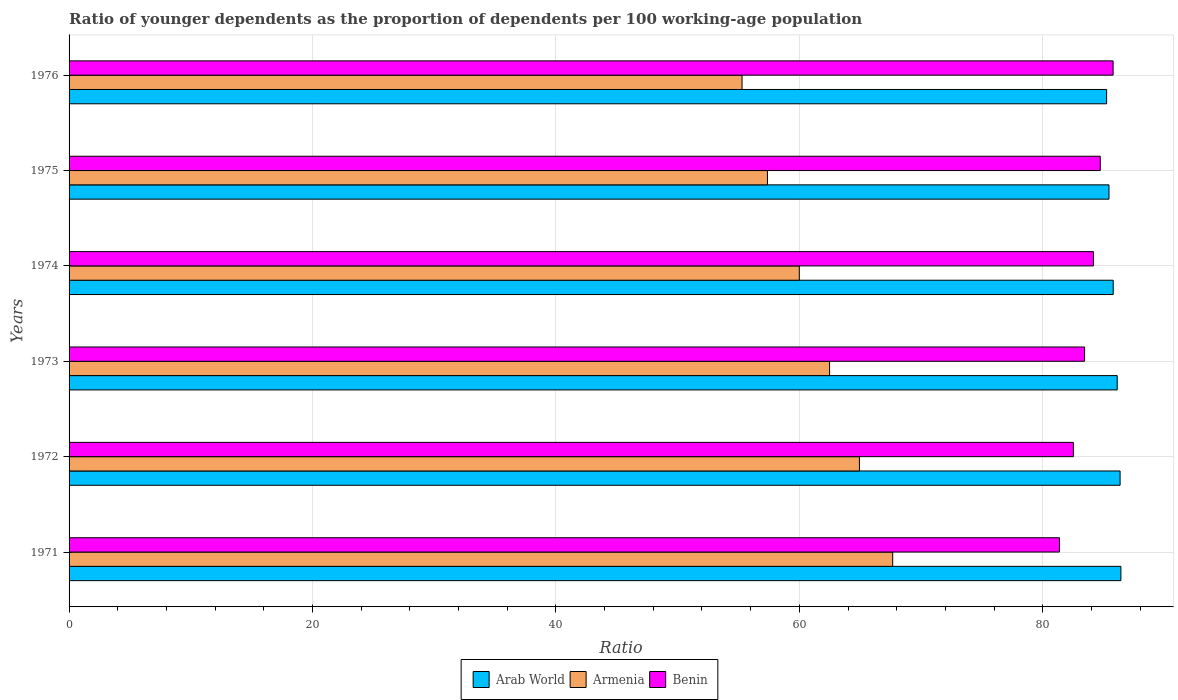Are the number of bars per tick equal to the number of legend labels?
Make the answer very short. Yes. How many bars are there on the 2nd tick from the top?
Ensure brevity in your answer.  3. What is the label of the 4th group of bars from the top?
Offer a terse response. 1973. In how many cases, is the number of bars for a given year not equal to the number of legend labels?
Keep it short and to the point. 0. What is the age dependency ratio(young) in Armenia in 1976?
Offer a very short reply. 55.29. Across all years, what is the maximum age dependency ratio(young) in Armenia?
Offer a very short reply. 67.67. Across all years, what is the minimum age dependency ratio(young) in Armenia?
Make the answer very short. 55.29. In which year was the age dependency ratio(young) in Arab World minimum?
Your response must be concise. 1976. What is the total age dependency ratio(young) in Armenia in the graph?
Provide a short and direct response. 367.76. What is the difference between the age dependency ratio(young) in Benin in 1975 and that in 1976?
Provide a short and direct response. -1.06. What is the difference between the age dependency ratio(young) in Armenia in 1971 and the age dependency ratio(young) in Benin in 1974?
Offer a terse response. -16.49. What is the average age dependency ratio(young) in Armenia per year?
Provide a short and direct response. 61.29. In the year 1971, what is the difference between the age dependency ratio(young) in Armenia and age dependency ratio(young) in Arab World?
Give a very brief answer. -18.75. In how many years, is the age dependency ratio(young) in Arab World greater than 48 ?
Provide a short and direct response. 6. What is the ratio of the age dependency ratio(young) in Armenia in 1971 to that in 1973?
Keep it short and to the point. 1.08. What is the difference between the highest and the second highest age dependency ratio(young) in Arab World?
Give a very brief answer. 0.07. What is the difference between the highest and the lowest age dependency ratio(young) in Armenia?
Ensure brevity in your answer.  12.38. What does the 2nd bar from the top in 1973 represents?
Your response must be concise. Armenia. What does the 1st bar from the bottom in 1974 represents?
Offer a very short reply. Arab World. How many bars are there?
Your answer should be very brief. 18. How many years are there in the graph?
Your answer should be compact. 6. What is the difference between two consecutive major ticks on the X-axis?
Offer a terse response. 20. Does the graph contain any zero values?
Make the answer very short. No. Does the graph contain grids?
Give a very brief answer. Yes. How many legend labels are there?
Your answer should be very brief. 3. How are the legend labels stacked?
Ensure brevity in your answer.  Horizontal. What is the title of the graph?
Keep it short and to the point. Ratio of younger dependents as the proportion of dependents per 100 working-age population. Does "Ethiopia" appear as one of the legend labels in the graph?
Provide a succinct answer. No. What is the label or title of the X-axis?
Your answer should be very brief. Ratio. What is the Ratio of Arab World in 1971?
Offer a terse response. 86.42. What is the Ratio in Armenia in 1971?
Offer a terse response. 67.67. What is the Ratio of Benin in 1971?
Your answer should be very brief. 81.37. What is the Ratio of Arab World in 1972?
Your answer should be very brief. 86.35. What is the Ratio of Armenia in 1972?
Keep it short and to the point. 64.94. What is the Ratio of Benin in 1972?
Your answer should be very brief. 82.52. What is the Ratio in Arab World in 1973?
Give a very brief answer. 86.12. What is the Ratio in Armenia in 1973?
Offer a very short reply. 62.48. What is the Ratio in Benin in 1973?
Ensure brevity in your answer.  83.44. What is the Ratio of Arab World in 1974?
Offer a very short reply. 85.79. What is the Ratio in Armenia in 1974?
Offer a terse response. 60. What is the Ratio in Benin in 1974?
Provide a short and direct response. 84.16. What is the Ratio in Arab World in 1975?
Ensure brevity in your answer.  85.44. What is the Ratio in Armenia in 1975?
Your response must be concise. 57.38. What is the Ratio of Benin in 1975?
Your response must be concise. 84.72. What is the Ratio of Arab World in 1976?
Your response must be concise. 85.25. What is the Ratio of Armenia in 1976?
Keep it short and to the point. 55.29. What is the Ratio of Benin in 1976?
Offer a terse response. 85.78. Across all years, what is the maximum Ratio in Arab World?
Your answer should be very brief. 86.42. Across all years, what is the maximum Ratio in Armenia?
Ensure brevity in your answer.  67.67. Across all years, what is the maximum Ratio in Benin?
Provide a short and direct response. 85.78. Across all years, what is the minimum Ratio in Arab World?
Keep it short and to the point. 85.25. Across all years, what is the minimum Ratio of Armenia?
Keep it short and to the point. 55.29. Across all years, what is the minimum Ratio of Benin?
Make the answer very short. 81.37. What is the total Ratio in Arab World in the graph?
Keep it short and to the point. 515.36. What is the total Ratio in Armenia in the graph?
Provide a short and direct response. 367.76. What is the total Ratio of Benin in the graph?
Provide a succinct answer. 501.99. What is the difference between the Ratio in Arab World in 1971 and that in 1972?
Give a very brief answer. 0.07. What is the difference between the Ratio in Armenia in 1971 and that in 1972?
Make the answer very short. 2.73. What is the difference between the Ratio of Benin in 1971 and that in 1972?
Your answer should be compact. -1.14. What is the difference between the Ratio of Arab World in 1971 and that in 1973?
Offer a very short reply. 0.3. What is the difference between the Ratio in Armenia in 1971 and that in 1973?
Ensure brevity in your answer.  5.19. What is the difference between the Ratio of Benin in 1971 and that in 1973?
Give a very brief answer. -2.06. What is the difference between the Ratio of Arab World in 1971 and that in 1974?
Provide a succinct answer. 0.63. What is the difference between the Ratio in Armenia in 1971 and that in 1974?
Make the answer very short. 7.67. What is the difference between the Ratio in Benin in 1971 and that in 1974?
Provide a succinct answer. -2.79. What is the difference between the Ratio in Arab World in 1971 and that in 1975?
Ensure brevity in your answer.  0.98. What is the difference between the Ratio of Armenia in 1971 and that in 1975?
Make the answer very short. 10.29. What is the difference between the Ratio of Benin in 1971 and that in 1975?
Your response must be concise. -3.35. What is the difference between the Ratio in Arab World in 1971 and that in 1976?
Keep it short and to the point. 1.17. What is the difference between the Ratio of Armenia in 1971 and that in 1976?
Offer a very short reply. 12.38. What is the difference between the Ratio in Benin in 1971 and that in 1976?
Your answer should be very brief. -4.41. What is the difference between the Ratio of Arab World in 1972 and that in 1973?
Your response must be concise. 0.24. What is the difference between the Ratio in Armenia in 1972 and that in 1973?
Provide a short and direct response. 2.45. What is the difference between the Ratio in Benin in 1972 and that in 1973?
Provide a succinct answer. -0.92. What is the difference between the Ratio in Arab World in 1972 and that in 1974?
Provide a succinct answer. 0.56. What is the difference between the Ratio in Armenia in 1972 and that in 1974?
Give a very brief answer. 4.94. What is the difference between the Ratio in Benin in 1972 and that in 1974?
Provide a short and direct response. -1.65. What is the difference between the Ratio in Arab World in 1972 and that in 1975?
Your response must be concise. 0.91. What is the difference between the Ratio in Armenia in 1972 and that in 1975?
Keep it short and to the point. 7.56. What is the difference between the Ratio in Benin in 1972 and that in 1975?
Your response must be concise. -2.21. What is the difference between the Ratio in Arab World in 1972 and that in 1976?
Ensure brevity in your answer.  1.11. What is the difference between the Ratio in Armenia in 1972 and that in 1976?
Provide a succinct answer. 9.64. What is the difference between the Ratio of Benin in 1972 and that in 1976?
Ensure brevity in your answer.  -3.26. What is the difference between the Ratio of Arab World in 1973 and that in 1974?
Your response must be concise. 0.33. What is the difference between the Ratio of Armenia in 1973 and that in 1974?
Your response must be concise. 2.49. What is the difference between the Ratio in Benin in 1973 and that in 1974?
Keep it short and to the point. -0.73. What is the difference between the Ratio in Arab World in 1973 and that in 1975?
Ensure brevity in your answer.  0.68. What is the difference between the Ratio of Armenia in 1973 and that in 1975?
Your answer should be very brief. 5.1. What is the difference between the Ratio in Benin in 1973 and that in 1975?
Ensure brevity in your answer.  -1.29. What is the difference between the Ratio of Arab World in 1973 and that in 1976?
Give a very brief answer. 0.87. What is the difference between the Ratio of Armenia in 1973 and that in 1976?
Your answer should be very brief. 7.19. What is the difference between the Ratio of Benin in 1973 and that in 1976?
Make the answer very short. -2.34. What is the difference between the Ratio of Arab World in 1974 and that in 1975?
Provide a succinct answer. 0.35. What is the difference between the Ratio in Armenia in 1974 and that in 1975?
Offer a terse response. 2.62. What is the difference between the Ratio in Benin in 1974 and that in 1975?
Give a very brief answer. -0.56. What is the difference between the Ratio of Arab World in 1974 and that in 1976?
Your answer should be compact. 0.54. What is the difference between the Ratio of Armenia in 1974 and that in 1976?
Your response must be concise. 4.7. What is the difference between the Ratio of Benin in 1974 and that in 1976?
Provide a short and direct response. -1.62. What is the difference between the Ratio of Arab World in 1975 and that in 1976?
Ensure brevity in your answer.  0.19. What is the difference between the Ratio in Armenia in 1975 and that in 1976?
Make the answer very short. 2.09. What is the difference between the Ratio in Benin in 1975 and that in 1976?
Your response must be concise. -1.06. What is the difference between the Ratio of Arab World in 1971 and the Ratio of Armenia in 1972?
Offer a terse response. 21.48. What is the difference between the Ratio of Arab World in 1971 and the Ratio of Benin in 1972?
Your answer should be compact. 3.9. What is the difference between the Ratio of Armenia in 1971 and the Ratio of Benin in 1972?
Provide a short and direct response. -14.85. What is the difference between the Ratio of Arab World in 1971 and the Ratio of Armenia in 1973?
Keep it short and to the point. 23.94. What is the difference between the Ratio in Arab World in 1971 and the Ratio in Benin in 1973?
Provide a succinct answer. 2.98. What is the difference between the Ratio in Armenia in 1971 and the Ratio in Benin in 1973?
Provide a short and direct response. -15.77. What is the difference between the Ratio of Arab World in 1971 and the Ratio of Armenia in 1974?
Provide a succinct answer. 26.42. What is the difference between the Ratio of Arab World in 1971 and the Ratio of Benin in 1974?
Provide a short and direct response. 2.26. What is the difference between the Ratio in Armenia in 1971 and the Ratio in Benin in 1974?
Offer a terse response. -16.49. What is the difference between the Ratio in Arab World in 1971 and the Ratio in Armenia in 1975?
Your answer should be very brief. 29.04. What is the difference between the Ratio in Arab World in 1971 and the Ratio in Benin in 1975?
Keep it short and to the point. 1.7. What is the difference between the Ratio of Armenia in 1971 and the Ratio of Benin in 1975?
Your response must be concise. -17.05. What is the difference between the Ratio of Arab World in 1971 and the Ratio of Armenia in 1976?
Your answer should be compact. 31.13. What is the difference between the Ratio of Arab World in 1971 and the Ratio of Benin in 1976?
Provide a short and direct response. 0.64. What is the difference between the Ratio of Armenia in 1971 and the Ratio of Benin in 1976?
Keep it short and to the point. -18.11. What is the difference between the Ratio in Arab World in 1972 and the Ratio in Armenia in 1973?
Offer a very short reply. 23.87. What is the difference between the Ratio of Arab World in 1972 and the Ratio of Benin in 1973?
Your answer should be compact. 2.92. What is the difference between the Ratio in Armenia in 1972 and the Ratio in Benin in 1973?
Provide a succinct answer. -18.5. What is the difference between the Ratio in Arab World in 1972 and the Ratio in Armenia in 1974?
Offer a terse response. 26.36. What is the difference between the Ratio in Arab World in 1972 and the Ratio in Benin in 1974?
Offer a very short reply. 2.19. What is the difference between the Ratio in Armenia in 1972 and the Ratio in Benin in 1974?
Your response must be concise. -19.23. What is the difference between the Ratio of Arab World in 1972 and the Ratio of Armenia in 1975?
Your response must be concise. 28.97. What is the difference between the Ratio in Arab World in 1972 and the Ratio in Benin in 1975?
Give a very brief answer. 1.63. What is the difference between the Ratio in Armenia in 1972 and the Ratio in Benin in 1975?
Make the answer very short. -19.79. What is the difference between the Ratio of Arab World in 1972 and the Ratio of Armenia in 1976?
Your answer should be compact. 31.06. What is the difference between the Ratio of Arab World in 1972 and the Ratio of Benin in 1976?
Offer a terse response. 0.57. What is the difference between the Ratio in Armenia in 1972 and the Ratio in Benin in 1976?
Your response must be concise. -20.84. What is the difference between the Ratio in Arab World in 1973 and the Ratio in Armenia in 1974?
Offer a very short reply. 26.12. What is the difference between the Ratio of Arab World in 1973 and the Ratio of Benin in 1974?
Keep it short and to the point. 1.95. What is the difference between the Ratio of Armenia in 1973 and the Ratio of Benin in 1974?
Offer a terse response. -21.68. What is the difference between the Ratio in Arab World in 1973 and the Ratio in Armenia in 1975?
Make the answer very short. 28.74. What is the difference between the Ratio in Arab World in 1973 and the Ratio in Benin in 1975?
Provide a succinct answer. 1.39. What is the difference between the Ratio of Armenia in 1973 and the Ratio of Benin in 1975?
Offer a terse response. -22.24. What is the difference between the Ratio of Arab World in 1973 and the Ratio of Armenia in 1976?
Offer a very short reply. 30.82. What is the difference between the Ratio of Arab World in 1973 and the Ratio of Benin in 1976?
Give a very brief answer. 0.34. What is the difference between the Ratio in Armenia in 1973 and the Ratio in Benin in 1976?
Your answer should be compact. -23.3. What is the difference between the Ratio in Arab World in 1974 and the Ratio in Armenia in 1975?
Ensure brevity in your answer.  28.41. What is the difference between the Ratio of Arab World in 1974 and the Ratio of Benin in 1975?
Provide a succinct answer. 1.07. What is the difference between the Ratio in Armenia in 1974 and the Ratio in Benin in 1975?
Make the answer very short. -24.73. What is the difference between the Ratio of Arab World in 1974 and the Ratio of Armenia in 1976?
Ensure brevity in your answer.  30.5. What is the difference between the Ratio in Arab World in 1974 and the Ratio in Benin in 1976?
Make the answer very short. 0.01. What is the difference between the Ratio in Armenia in 1974 and the Ratio in Benin in 1976?
Offer a terse response. -25.78. What is the difference between the Ratio in Arab World in 1975 and the Ratio in Armenia in 1976?
Make the answer very short. 30.15. What is the difference between the Ratio in Arab World in 1975 and the Ratio in Benin in 1976?
Offer a terse response. -0.34. What is the difference between the Ratio in Armenia in 1975 and the Ratio in Benin in 1976?
Ensure brevity in your answer.  -28.4. What is the average Ratio of Arab World per year?
Your answer should be compact. 85.89. What is the average Ratio of Armenia per year?
Ensure brevity in your answer.  61.29. What is the average Ratio in Benin per year?
Offer a terse response. 83.66. In the year 1971, what is the difference between the Ratio in Arab World and Ratio in Armenia?
Offer a terse response. 18.75. In the year 1971, what is the difference between the Ratio of Arab World and Ratio of Benin?
Your response must be concise. 5.05. In the year 1971, what is the difference between the Ratio of Armenia and Ratio of Benin?
Ensure brevity in your answer.  -13.7. In the year 1972, what is the difference between the Ratio in Arab World and Ratio in Armenia?
Provide a succinct answer. 21.42. In the year 1972, what is the difference between the Ratio in Arab World and Ratio in Benin?
Your answer should be compact. 3.84. In the year 1972, what is the difference between the Ratio of Armenia and Ratio of Benin?
Give a very brief answer. -17.58. In the year 1973, what is the difference between the Ratio of Arab World and Ratio of Armenia?
Offer a terse response. 23.63. In the year 1973, what is the difference between the Ratio in Arab World and Ratio in Benin?
Offer a terse response. 2.68. In the year 1973, what is the difference between the Ratio in Armenia and Ratio in Benin?
Ensure brevity in your answer.  -20.95. In the year 1974, what is the difference between the Ratio in Arab World and Ratio in Armenia?
Your answer should be very brief. 25.79. In the year 1974, what is the difference between the Ratio in Arab World and Ratio in Benin?
Provide a short and direct response. 1.62. In the year 1974, what is the difference between the Ratio of Armenia and Ratio of Benin?
Keep it short and to the point. -24.17. In the year 1975, what is the difference between the Ratio of Arab World and Ratio of Armenia?
Keep it short and to the point. 28.06. In the year 1975, what is the difference between the Ratio of Arab World and Ratio of Benin?
Your answer should be compact. 0.72. In the year 1975, what is the difference between the Ratio of Armenia and Ratio of Benin?
Offer a terse response. -27.34. In the year 1976, what is the difference between the Ratio in Arab World and Ratio in Armenia?
Keep it short and to the point. 29.95. In the year 1976, what is the difference between the Ratio of Arab World and Ratio of Benin?
Keep it short and to the point. -0.53. In the year 1976, what is the difference between the Ratio in Armenia and Ratio in Benin?
Keep it short and to the point. -30.49. What is the ratio of the Ratio in Armenia in 1971 to that in 1972?
Your answer should be compact. 1.04. What is the ratio of the Ratio in Benin in 1971 to that in 1972?
Your answer should be very brief. 0.99. What is the ratio of the Ratio in Armenia in 1971 to that in 1973?
Provide a succinct answer. 1.08. What is the ratio of the Ratio in Benin in 1971 to that in 1973?
Give a very brief answer. 0.98. What is the ratio of the Ratio in Arab World in 1971 to that in 1974?
Offer a very short reply. 1.01. What is the ratio of the Ratio in Armenia in 1971 to that in 1974?
Your answer should be compact. 1.13. What is the ratio of the Ratio of Benin in 1971 to that in 1974?
Provide a succinct answer. 0.97. What is the ratio of the Ratio of Arab World in 1971 to that in 1975?
Your answer should be compact. 1.01. What is the ratio of the Ratio of Armenia in 1971 to that in 1975?
Your answer should be compact. 1.18. What is the ratio of the Ratio of Benin in 1971 to that in 1975?
Give a very brief answer. 0.96. What is the ratio of the Ratio in Arab World in 1971 to that in 1976?
Keep it short and to the point. 1.01. What is the ratio of the Ratio in Armenia in 1971 to that in 1976?
Your answer should be very brief. 1.22. What is the ratio of the Ratio of Benin in 1971 to that in 1976?
Provide a short and direct response. 0.95. What is the ratio of the Ratio in Arab World in 1972 to that in 1973?
Offer a terse response. 1. What is the ratio of the Ratio of Armenia in 1972 to that in 1973?
Your response must be concise. 1.04. What is the ratio of the Ratio in Arab World in 1972 to that in 1974?
Give a very brief answer. 1.01. What is the ratio of the Ratio of Armenia in 1972 to that in 1974?
Make the answer very short. 1.08. What is the ratio of the Ratio in Benin in 1972 to that in 1974?
Your answer should be compact. 0.98. What is the ratio of the Ratio of Arab World in 1972 to that in 1975?
Offer a very short reply. 1.01. What is the ratio of the Ratio in Armenia in 1972 to that in 1975?
Offer a terse response. 1.13. What is the ratio of the Ratio of Benin in 1972 to that in 1975?
Offer a very short reply. 0.97. What is the ratio of the Ratio of Arab World in 1972 to that in 1976?
Your answer should be compact. 1.01. What is the ratio of the Ratio in Armenia in 1972 to that in 1976?
Offer a very short reply. 1.17. What is the ratio of the Ratio in Armenia in 1973 to that in 1974?
Ensure brevity in your answer.  1.04. What is the ratio of the Ratio in Benin in 1973 to that in 1974?
Offer a very short reply. 0.99. What is the ratio of the Ratio in Arab World in 1973 to that in 1975?
Provide a short and direct response. 1.01. What is the ratio of the Ratio in Armenia in 1973 to that in 1975?
Your answer should be compact. 1.09. What is the ratio of the Ratio of Arab World in 1973 to that in 1976?
Offer a terse response. 1.01. What is the ratio of the Ratio in Armenia in 1973 to that in 1976?
Your response must be concise. 1.13. What is the ratio of the Ratio of Benin in 1973 to that in 1976?
Your answer should be compact. 0.97. What is the ratio of the Ratio of Armenia in 1974 to that in 1975?
Give a very brief answer. 1.05. What is the ratio of the Ratio in Benin in 1974 to that in 1975?
Give a very brief answer. 0.99. What is the ratio of the Ratio of Arab World in 1974 to that in 1976?
Provide a short and direct response. 1.01. What is the ratio of the Ratio in Armenia in 1974 to that in 1976?
Offer a terse response. 1.09. What is the ratio of the Ratio in Benin in 1974 to that in 1976?
Make the answer very short. 0.98. What is the ratio of the Ratio of Arab World in 1975 to that in 1976?
Provide a succinct answer. 1. What is the ratio of the Ratio in Armenia in 1975 to that in 1976?
Your response must be concise. 1.04. What is the ratio of the Ratio in Benin in 1975 to that in 1976?
Provide a succinct answer. 0.99. What is the difference between the highest and the second highest Ratio in Arab World?
Your response must be concise. 0.07. What is the difference between the highest and the second highest Ratio of Armenia?
Provide a short and direct response. 2.73. What is the difference between the highest and the second highest Ratio in Benin?
Your answer should be very brief. 1.06. What is the difference between the highest and the lowest Ratio in Arab World?
Provide a succinct answer. 1.17. What is the difference between the highest and the lowest Ratio in Armenia?
Offer a terse response. 12.38. What is the difference between the highest and the lowest Ratio of Benin?
Keep it short and to the point. 4.41. 